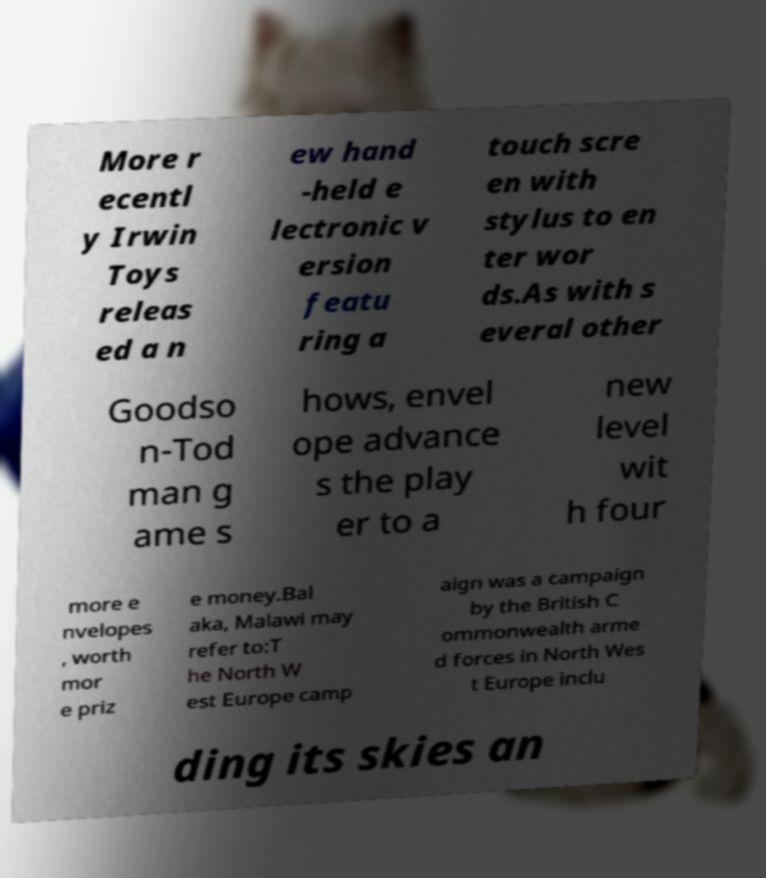Please identify and transcribe the text found in this image. More r ecentl y Irwin Toys releas ed a n ew hand -held e lectronic v ersion featu ring a touch scre en with stylus to en ter wor ds.As with s everal other Goodso n-Tod man g ame s hows, envel ope advance s the play er to a new level wit h four more e nvelopes , worth mor e priz e money.Bal aka, Malawi may refer to:T he North W est Europe camp aign was a campaign by the British C ommonwealth arme d forces in North Wes t Europe inclu ding its skies an 